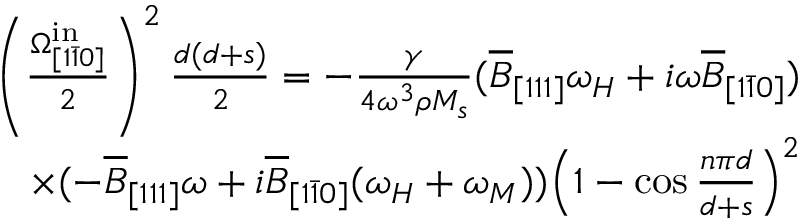Convert formula to latex. <formula><loc_0><loc_0><loc_500><loc_500>\begin{array} { r } { \left ( \frac { \Omega _ { [ 1 \bar { 1 } 0 ] } ^ { i n } } { 2 } \right ) ^ { 2 } \frac { d ( d + s ) } { 2 } = - \frac { \gamma } { 4 \omega ^ { 3 } \rho M _ { s } } ( \overline { B } _ { [ 1 1 1 ] } \omega _ { H } + i \omega \overline { B } _ { [ 1 \bar { 1 } 0 ] } ) } \\ { \times ( - \overline { B } _ { [ 1 1 1 ] } \omega + i \overline { B } _ { [ 1 \bar { 1 } 0 ] } ( \omega _ { H } + \omega _ { M } ) ) \left ( 1 - \cos { \frac { n \pi d } { d + s } } \right ) ^ { 2 } } \end{array}</formula> 